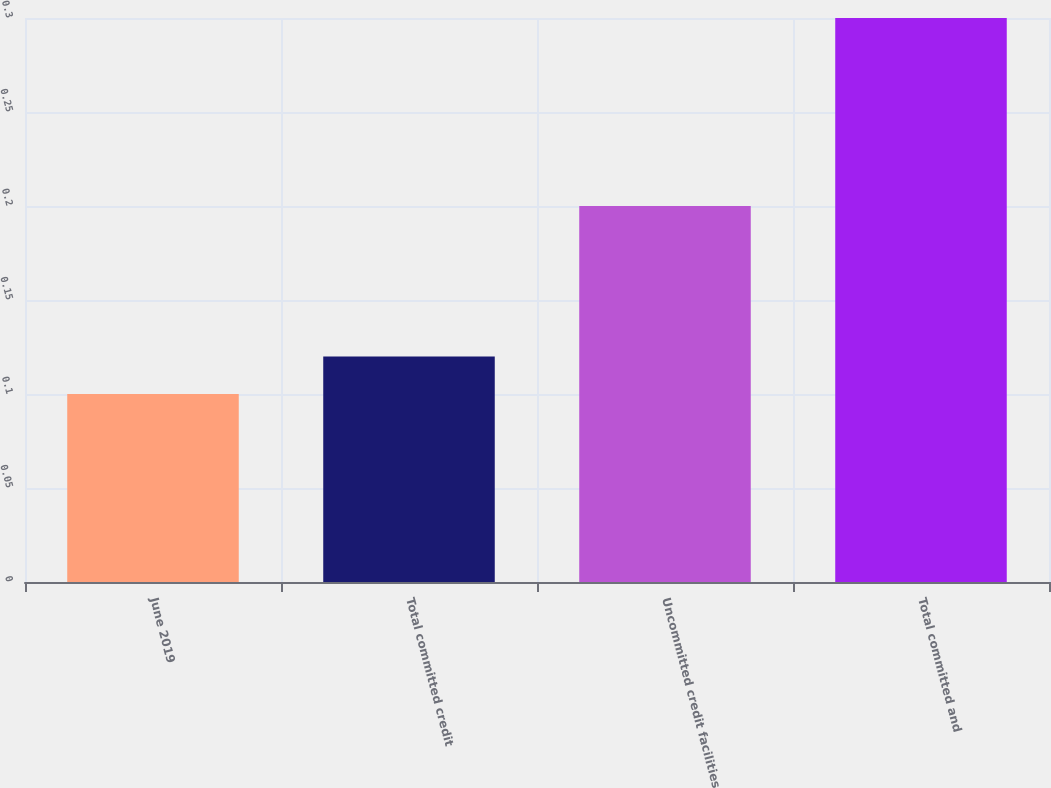<chart> <loc_0><loc_0><loc_500><loc_500><bar_chart><fcel>June 2019<fcel>Total committed credit<fcel>Uncommitted credit facilities<fcel>Total committed and<nl><fcel>0.1<fcel>0.12<fcel>0.2<fcel>0.3<nl></chart> 